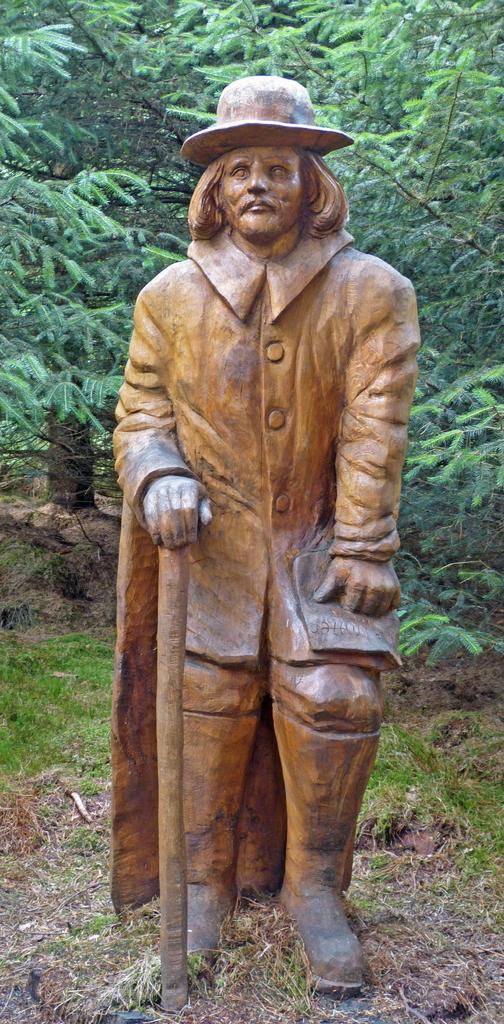What is the main subject in the foreground of the image? There is a sculpture of a man in the foreground of the image. How is the sculpture positioned in the image? The sculpture is on the ground. What can be seen in the background of the image? There are trees and grass visible in the background of the image. What type of leather is used to make the scarecrow in the image? There is no scarecrow present in the image; it features a sculpture of a man. What type of picture is hanging on the wall in the image? There is no wall or picture present in the image; it features a sculpture of a man on the ground with trees and grass in the background. 